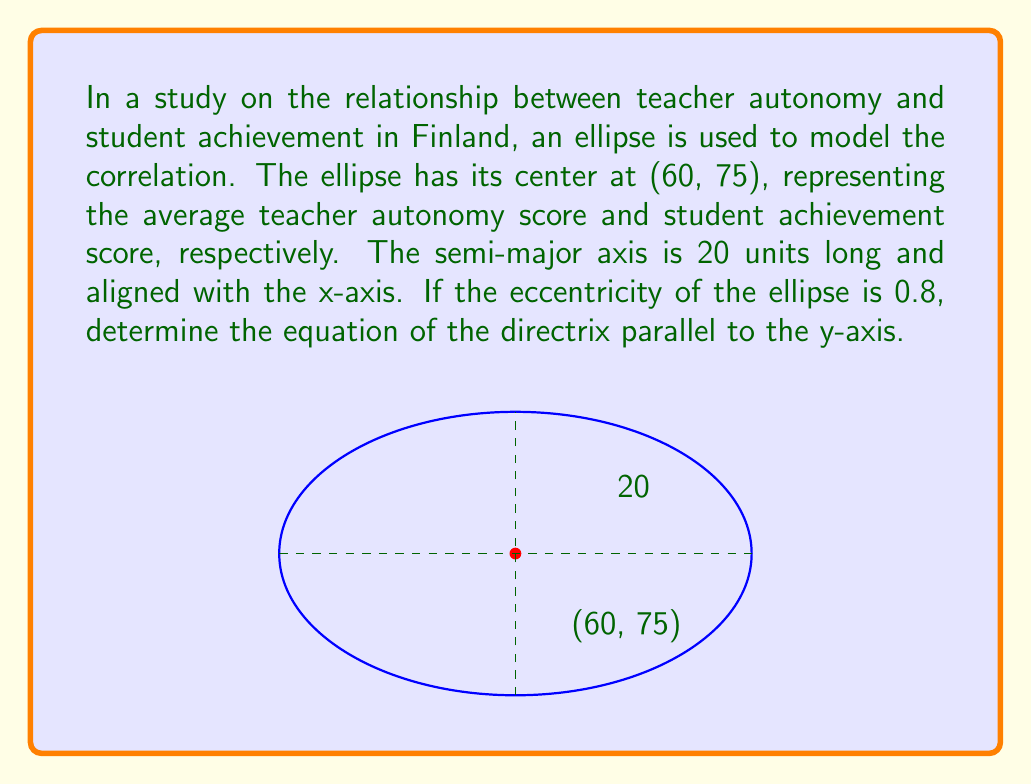Help me with this question. Let's approach this step-by-step:

1) The general equation of an ellipse with center (h,k) is:
   $$\frac{(x-h)^2}{a^2} + \frac{(y-k)^2}{b^2} = 1$$

2) We're given that the center is at (60,75), so h = 60 and k = 75.

3) The semi-major axis a = 20.

4) The eccentricity e = 0.8. We can use this to find c:
   $$e = \frac{c}{a}$$
   $$0.8 = \frac{c}{20}$$
   $$c = 16$$

5) For an ellipse, $a^2 = b^2 + c^2$. We can use this to find b:
   $$20^2 = b^2 + 16^2$$
   $$400 = b^2 + 256$$
   $$b^2 = 144$$
   $$b = 12$$

6) The equation of the directrix for an ellipse with center (h,k) and major axis parallel to the x-axis is:
   $$x = h \pm \frac{a}{e}$$

7) In this case, we want the equation parallel to the y-axis, so we use:
   $$x = 60 - \frac{20}{0.8} = 60 - 25 = 35$$

   Note: We subtract because the directrix is on the left side of the center.
Answer: $x = 35$ 